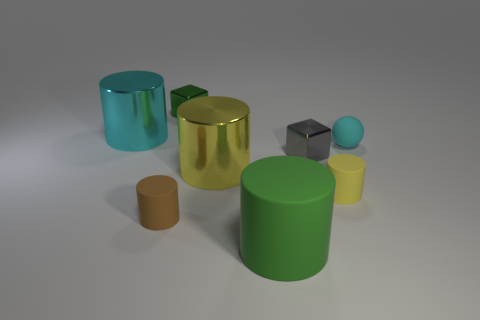What color is the big object that is behind the big yellow shiny cylinder?
Give a very brief answer. Cyan. What number of other objects are the same color as the big matte thing?
Offer a terse response. 1. Is the size of the metallic cylinder to the right of the brown matte cylinder the same as the small brown matte thing?
Your answer should be very brief. No. There is a big cyan metal cylinder; how many green cubes are on the right side of it?
Provide a short and direct response. 1. Are there any purple spheres that have the same size as the gray metal thing?
Your answer should be compact. No. There is a big metal thing that is on the left side of the small brown cylinder that is to the left of the small green thing; what color is it?
Offer a very short reply. Cyan. What number of objects are both on the right side of the small brown cylinder and left of the tiny yellow object?
Your answer should be very brief. 4. How many small yellow things are the same shape as the big green object?
Give a very brief answer. 1. Are the large yellow cylinder and the small gray thing made of the same material?
Ensure brevity in your answer.  Yes. What shape is the tiny object behind the big cyan shiny thing that is behind the sphere?
Ensure brevity in your answer.  Cube. 